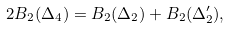<formula> <loc_0><loc_0><loc_500><loc_500>2 B _ { 2 } ( \Delta _ { 4 } ) = B _ { 2 } ( \Delta _ { 2 } ) + B _ { 2 } ( \Delta _ { 2 } ^ { \prime } ) ,</formula> 